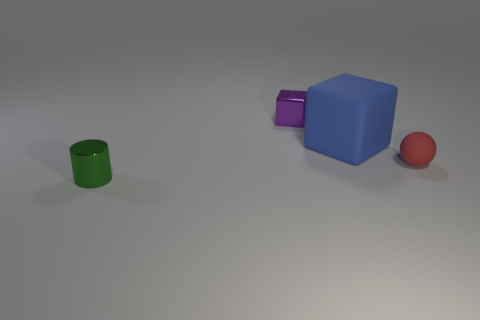What number of objects are either things to the right of the large blue cube or shiny objects behind the small matte object?
Provide a short and direct response. 2. How many other objects are the same shape as the big thing?
Keep it short and to the point. 1. There is a tiny object that is behind the tiny red matte ball; is its color the same as the tiny shiny cylinder?
Your answer should be compact. No. What number of other things are the same size as the blue matte cube?
Make the answer very short. 0. Are the sphere and the tiny green cylinder made of the same material?
Offer a very short reply. No. What color is the small metallic thing that is to the right of the small metal object that is to the left of the purple metallic object?
Offer a very short reply. Purple. What is the size of the other object that is the same shape as the tiny purple object?
Offer a very short reply. Large. Do the large object and the small rubber thing have the same color?
Give a very brief answer. No. How many metallic things are in front of the small shiny object that is right of the small green shiny cylinder that is in front of the purple thing?
Keep it short and to the point. 1. Is the number of shiny cubes greater than the number of big gray metallic things?
Offer a very short reply. Yes. 